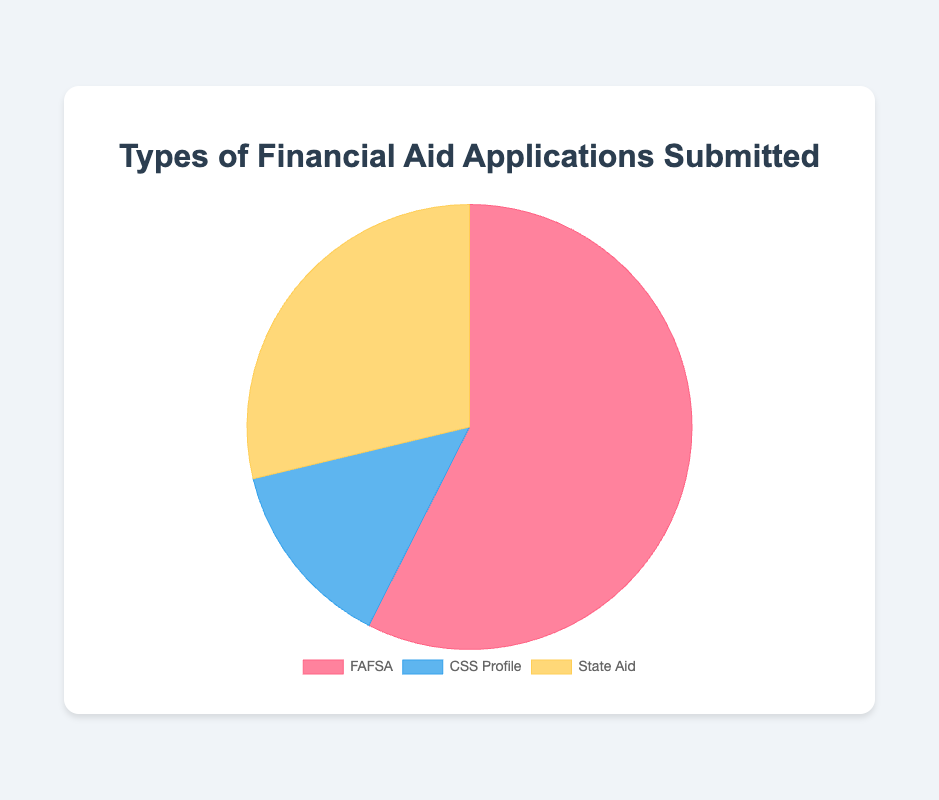What is the total number of financial aid applications submitted? To find the total number of applications submitted, add the numbers for each application type: FAFSA (5,000,000) + CSS Profile (1,200,000) + State Aid (2,500,000). Summing these values gives 8,700,000 applications.
Answer: 8,700,000 Which type of financial aid application is the most frequently submitted? Compare the numbers for each application type: FAFSA (5,000,000), CSS Profile (1,200,000), and State Aid (2,500,000). FAFSA has the highest number of applications.
Answer: FAFSA How many more FAFSA applications were submitted compared to CSS Profile applications? Subtract the number of CSS Profile applications (1,200,000) from the number of FAFSA applications (5,000,000). The difference is 5,000,000 - 1,200,000 = 3,800,000 applications.
Answer: 3,800,000 What percentage of the total applications does the State Aid category represent? Divide the number of State Aid applications (2,500,000) by the total number of applications (8,700,000), then multiply by 100. The calculation is (2,500,000 / 8,700,000) * 100 ≈ 28.74%.
Answer: 28.74% How do the numbers of FAFSA and State Aid applications compare? Compare FAFSA (5,000,000) and State Aid (2,500,000) by identifying which is greater. FAFSA has more applications.
Answer: FAFSA > State Aid What is the average number of applications across all three types? Sum the total number of applications for all types (8,700,000) and divide by the number of types (3). The calculation is 8,700,000 / 3 = 2,900,000 applications.
Answer: 2,900,000 Which type of financial aid application has the smallest number of submissions? Compare FAFSA (5,000,000), CSS Profile (1,200,000), and State Aid (2,500,000). CSS Profile has the smallest number of applications.
Answer: CSS Profile What is the combined number of applications for CSS Profile and State Aid? Add the number of CSS Profile applications (1,200,000) and State Aid applications (2,500,000). The total is 1,200,000 + 2,500,000 = 3,700,000 applications.
Answer: 3,700,000 What fraction of the total applications is represented by FAFSA applications? Divide the number of FAFSA applications (5,000,000) by the total applications (8,700,000). The fraction is 5,000,000 / 8,700,000 = 5/8.7. Simplifying this fraction gives ≈ 0.5747 or 57.47%.
Answer: 57.47% What color represents the CSS Profile applications in the pie chart? Observe the colors assigned to each application type in the visualization: FAFSA (red), CSS Profile (blue), State Aid (yellow). CSS Profile is represented by blue.
Answer: Blue 